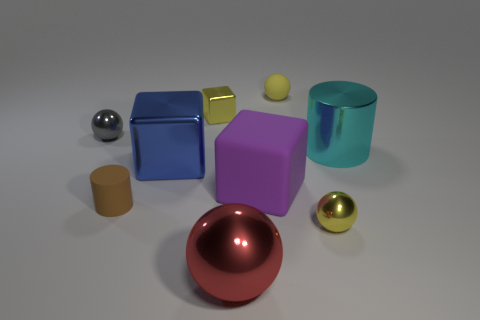Add 1 large green cylinders. How many objects exist? 10 Subtract all balls. How many objects are left? 5 Subtract 0 gray cylinders. How many objects are left? 9 Subtract all big things. Subtract all yellow metal blocks. How many objects are left? 4 Add 4 large purple things. How many large purple things are left? 5 Add 4 yellow objects. How many yellow objects exist? 7 